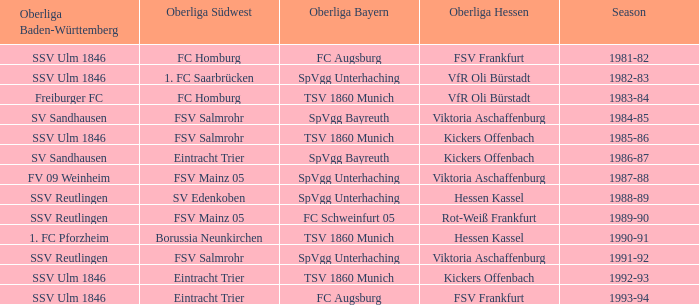Which oberliga baden-württemberg has a season of 1991-92? SSV Reutlingen. Could you help me parse every detail presented in this table? {'header': ['Oberliga Baden-Württemberg', 'Oberliga Südwest', 'Oberliga Bayern', 'Oberliga Hessen', 'Season'], 'rows': [['SSV Ulm 1846', 'FC Homburg', 'FC Augsburg', 'FSV Frankfurt', '1981-82'], ['SSV Ulm 1846', '1. FC Saarbrücken', 'SpVgg Unterhaching', 'VfR Oli Bürstadt', '1982-83'], ['Freiburger FC', 'FC Homburg', 'TSV 1860 Munich', 'VfR Oli Bürstadt', '1983-84'], ['SV Sandhausen', 'FSV Salmrohr', 'SpVgg Bayreuth', 'Viktoria Aschaffenburg', '1984-85'], ['SSV Ulm 1846', 'FSV Salmrohr', 'TSV 1860 Munich', 'Kickers Offenbach', '1985-86'], ['SV Sandhausen', 'Eintracht Trier', 'SpVgg Bayreuth', 'Kickers Offenbach', '1986-87'], ['FV 09 Weinheim', 'FSV Mainz 05', 'SpVgg Unterhaching', 'Viktoria Aschaffenburg', '1987-88'], ['SSV Reutlingen', 'SV Edenkoben', 'SpVgg Unterhaching', 'Hessen Kassel', '1988-89'], ['SSV Reutlingen', 'FSV Mainz 05', 'FC Schweinfurt 05', 'Rot-Weiß Frankfurt', '1989-90'], ['1. FC Pforzheim', 'Borussia Neunkirchen', 'TSV 1860 Munich', 'Hessen Kassel', '1990-91'], ['SSV Reutlingen', 'FSV Salmrohr', 'SpVgg Unterhaching', 'Viktoria Aschaffenburg', '1991-92'], ['SSV Ulm 1846', 'Eintracht Trier', 'TSV 1860 Munich', 'Kickers Offenbach', '1992-93'], ['SSV Ulm 1846', 'Eintracht Trier', 'FC Augsburg', 'FSV Frankfurt', '1993-94']]} 